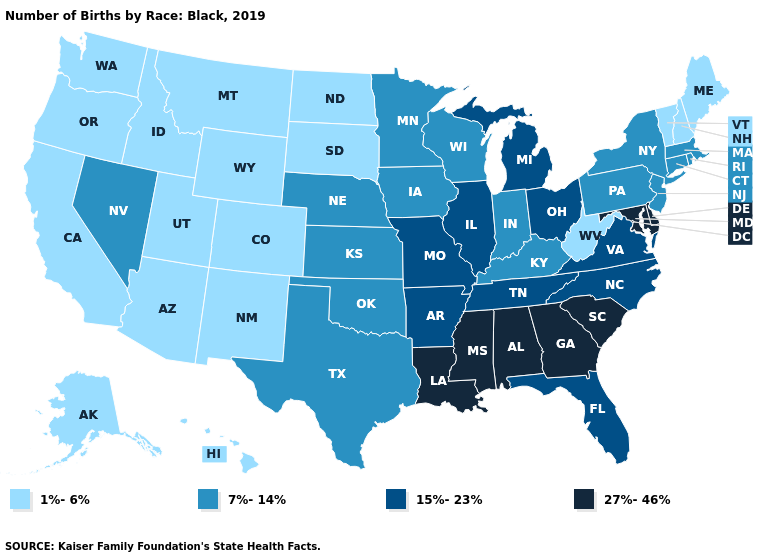Name the states that have a value in the range 27%-46%?
Write a very short answer. Alabama, Delaware, Georgia, Louisiana, Maryland, Mississippi, South Carolina. Among the states that border Indiana , does Kentucky have the lowest value?
Concise answer only. Yes. Among the states that border New York , does Massachusetts have the highest value?
Quick response, please. Yes. What is the value of Montana?
Be succinct. 1%-6%. Does the map have missing data?
Give a very brief answer. No. Does South Carolina have the highest value in the South?
Give a very brief answer. Yes. Does Oregon have a lower value than Connecticut?
Answer briefly. Yes. Among the states that border Colorado , does Kansas have the highest value?
Short answer required. Yes. Which states hav the highest value in the West?
Quick response, please. Nevada. Which states have the lowest value in the USA?
Concise answer only. Alaska, Arizona, California, Colorado, Hawaii, Idaho, Maine, Montana, New Hampshire, New Mexico, North Dakota, Oregon, South Dakota, Utah, Vermont, Washington, West Virginia, Wyoming. Among the states that border Texas , does Oklahoma have the lowest value?
Give a very brief answer. No. Among the states that border Virginia , does West Virginia have the lowest value?
Short answer required. Yes. Name the states that have a value in the range 7%-14%?
Short answer required. Connecticut, Indiana, Iowa, Kansas, Kentucky, Massachusetts, Minnesota, Nebraska, Nevada, New Jersey, New York, Oklahoma, Pennsylvania, Rhode Island, Texas, Wisconsin. Is the legend a continuous bar?
Answer briefly. No. Name the states that have a value in the range 7%-14%?
Give a very brief answer. Connecticut, Indiana, Iowa, Kansas, Kentucky, Massachusetts, Minnesota, Nebraska, Nevada, New Jersey, New York, Oklahoma, Pennsylvania, Rhode Island, Texas, Wisconsin. 